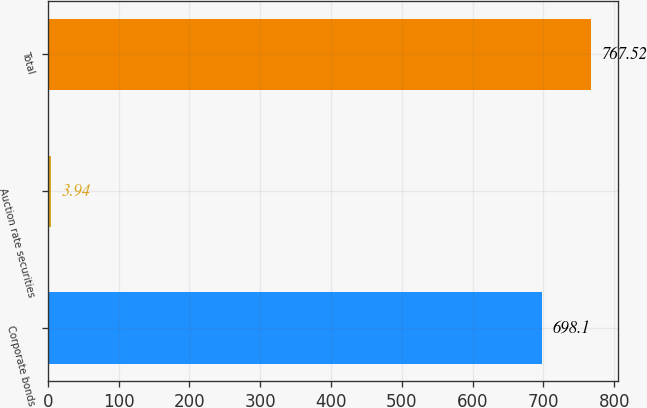Convert chart. <chart><loc_0><loc_0><loc_500><loc_500><bar_chart><fcel>Corporate bonds<fcel>Auction rate securities<fcel>Total<nl><fcel>698.1<fcel>3.94<fcel>767.52<nl></chart> 